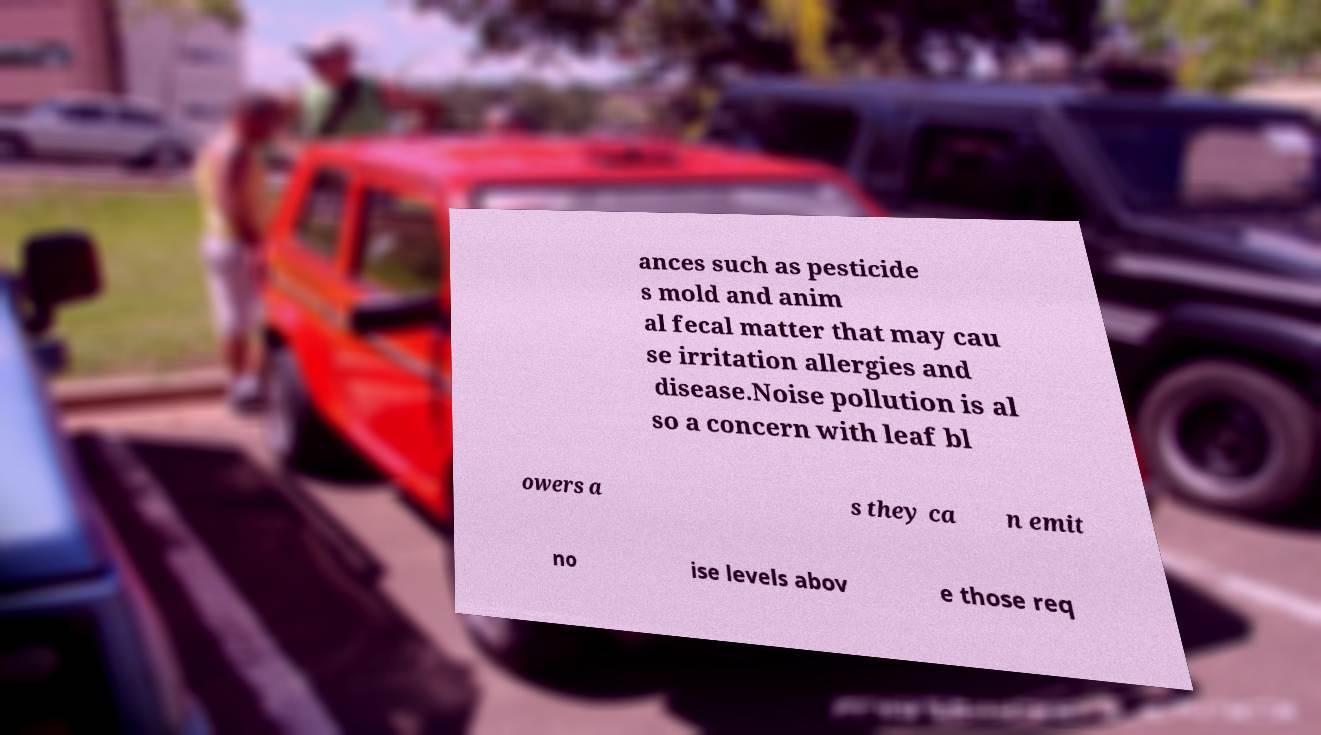There's text embedded in this image that I need extracted. Can you transcribe it verbatim? ances such as pesticide s mold and anim al fecal matter that may cau se irritation allergies and disease.Noise pollution is al so a concern with leaf bl owers a s they ca n emit no ise levels abov e those req 